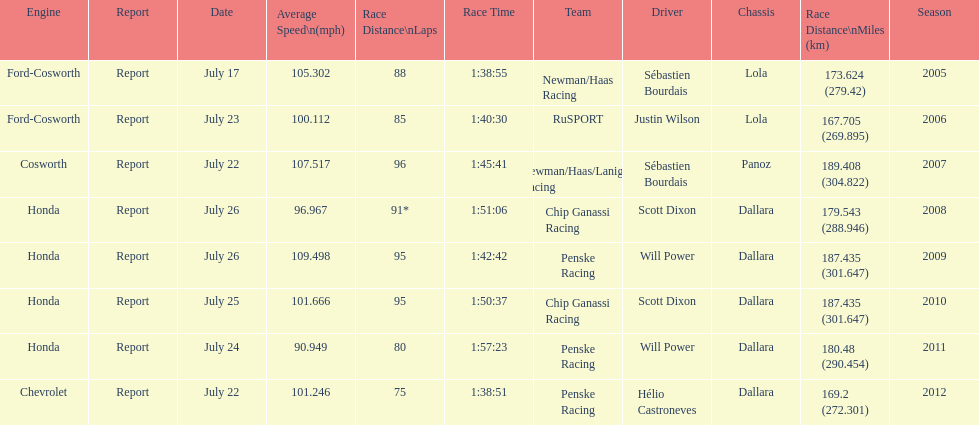How many different teams are represented in the table? 4. 